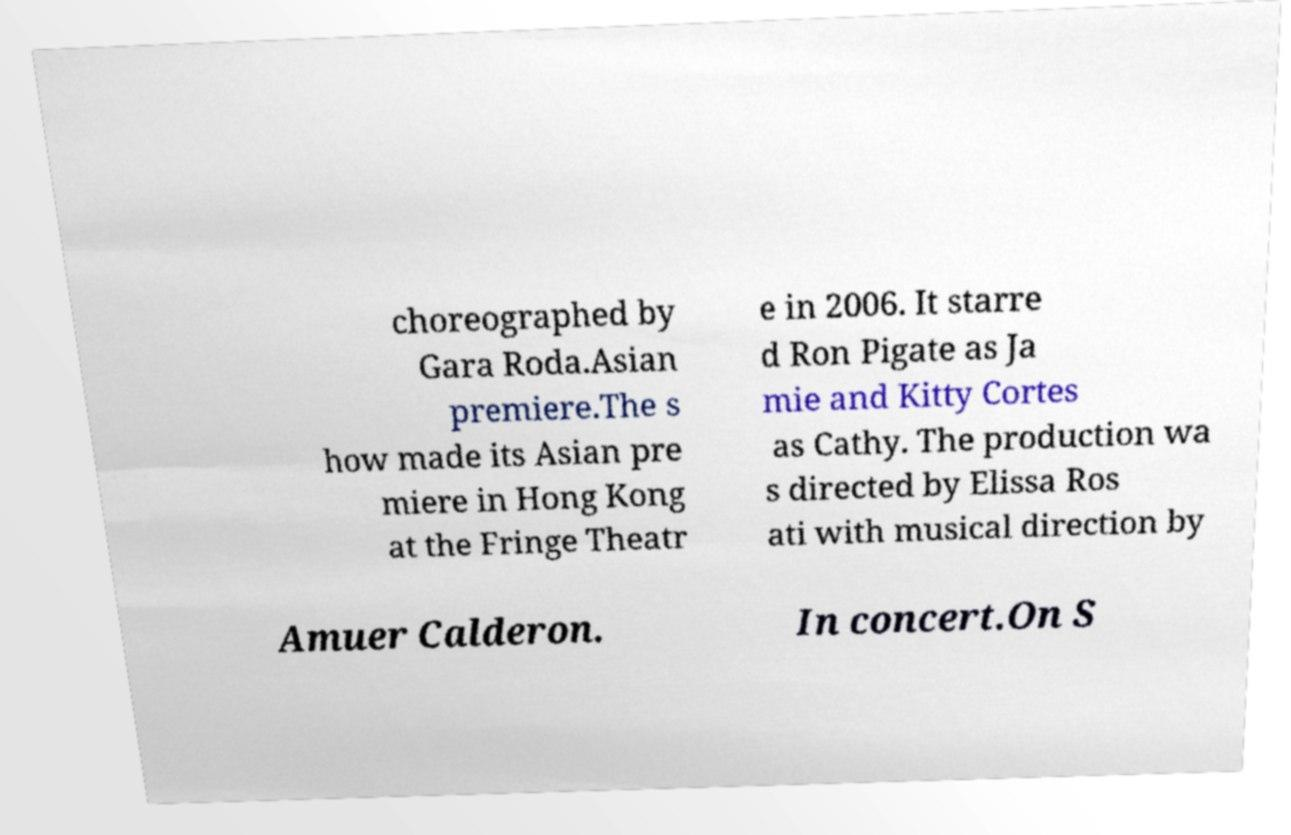Can you read and provide the text displayed in the image?This photo seems to have some interesting text. Can you extract and type it out for me? choreographed by Gara Roda.Asian premiere.The s how made its Asian pre miere in Hong Kong at the Fringe Theatr e in 2006. It starre d Ron Pigate as Ja mie and Kitty Cortes as Cathy. The production wa s directed by Elissa Ros ati with musical direction by Amuer Calderon. In concert.On S 